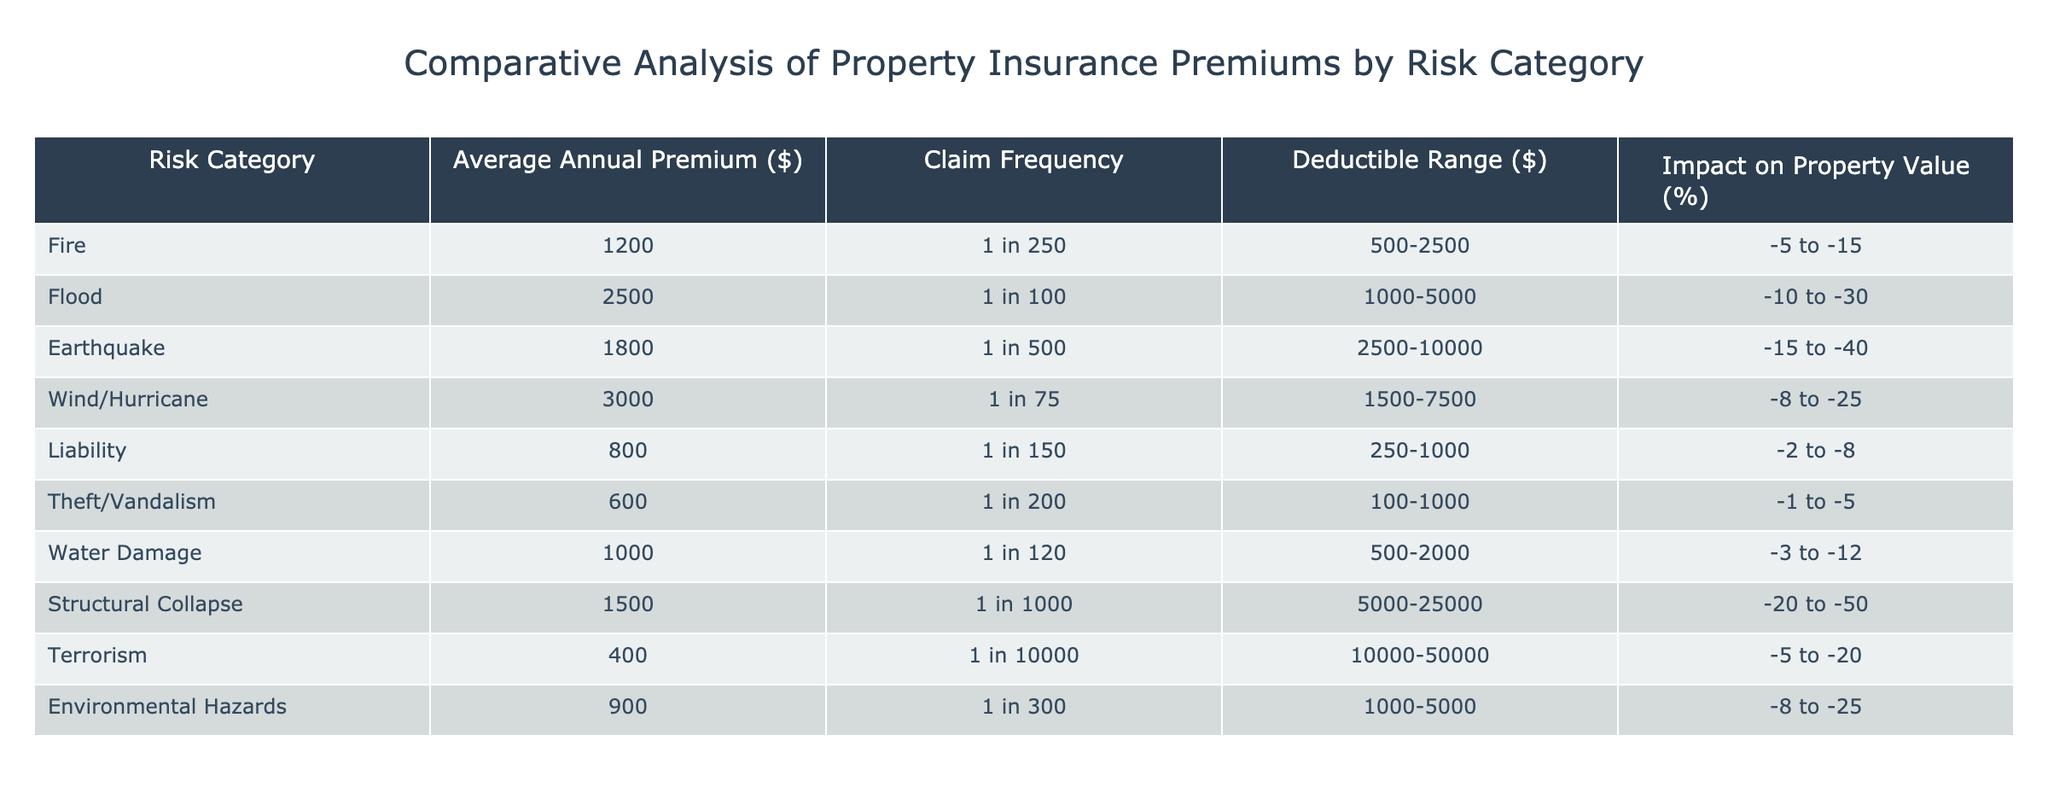What is the average annual premium for flood insurance? The table shows that the average annual premium for the flood risk category is listed directly under that category. The value is 2500.
Answer: 2500 Which risk category has the highest claim frequency? Claim frequency is provided in the table as a ratio involving a number that indicates how often claims are made. Comparing the values, the Wind/Hurricane category, with a frequency of 1 in 75, is the highest.
Answer: Wind/Hurricane What is the difference between the average annual premiums for wind/hurricane and theft/vandalism? To find the difference, we subtract the theft/vandalism premium (600) from the wind/hurricane premium (3000). The difference is 3000 - 600 = 2400.
Answer: 2400 Is the deductible range for environmental hazards higher than that for water damage? The deductible range for environmental hazards is from 1000 to 5000, while for water damage it is from 500 to 2000. Since the maximum of environmental hazards (5000) exceeds the maximum of water damage (2000), the statement is true.
Answer: Yes Which risk categories have an impact on property value greater than 20%? We look for categories where the impact on property value percentage range's lower limit is greater than -20%. Structural collapse (-20 to -50) meets this criterion. All other impacts are less than -20%. Thus, structural collapse is the only category that qualifies.
Answer: Structural Collapse 